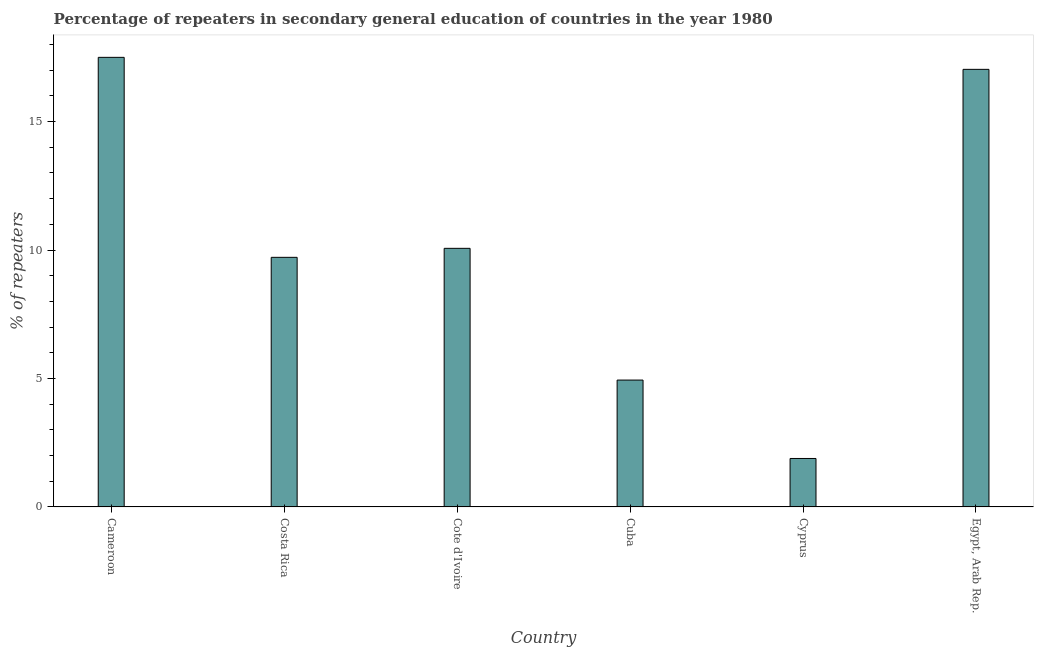Does the graph contain any zero values?
Your response must be concise. No. What is the title of the graph?
Offer a very short reply. Percentage of repeaters in secondary general education of countries in the year 1980. What is the label or title of the X-axis?
Provide a short and direct response. Country. What is the label or title of the Y-axis?
Provide a short and direct response. % of repeaters. What is the percentage of repeaters in Cote d'Ivoire?
Offer a terse response. 10.07. Across all countries, what is the maximum percentage of repeaters?
Provide a short and direct response. 17.5. Across all countries, what is the minimum percentage of repeaters?
Your response must be concise. 1.89. In which country was the percentage of repeaters maximum?
Offer a very short reply. Cameroon. In which country was the percentage of repeaters minimum?
Give a very brief answer. Cyprus. What is the sum of the percentage of repeaters?
Your answer should be compact. 61.13. What is the difference between the percentage of repeaters in Costa Rica and Egypt, Arab Rep.?
Offer a terse response. -7.32. What is the average percentage of repeaters per country?
Provide a short and direct response. 10.19. What is the median percentage of repeaters?
Give a very brief answer. 9.89. What is the ratio of the percentage of repeaters in Costa Rica to that in Cyprus?
Your answer should be very brief. 5.15. Is the percentage of repeaters in Cyprus less than that in Egypt, Arab Rep.?
Keep it short and to the point. Yes. Is the difference between the percentage of repeaters in Cote d'Ivoire and Cuba greater than the difference between any two countries?
Make the answer very short. No. What is the difference between the highest and the second highest percentage of repeaters?
Keep it short and to the point. 0.47. What is the difference between the highest and the lowest percentage of repeaters?
Keep it short and to the point. 15.61. How many bars are there?
Ensure brevity in your answer.  6. What is the difference between two consecutive major ticks on the Y-axis?
Ensure brevity in your answer.  5. Are the values on the major ticks of Y-axis written in scientific E-notation?
Make the answer very short. No. What is the % of repeaters of Cameroon?
Make the answer very short. 17.5. What is the % of repeaters of Costa Rica?
Keep it short and to the point. 9.71. What is the % of repeaters in Cote d'Ivoire?
Your answer should be very brief. 10.07. What is the % of repeaters of Cuba?
Give a very brief answer. 4.94. What is the % of repeaters of Cyprus?
Your response must be concise. 1.89. What is the % of repeaters in Egypt, Arab Rep.?
Offer a terse response. 17.03. What is the difference between the % of repeaters in Cameroon and Costa Rica?
Ensure brevity in your answer.  7.78. What is the difference between the % of repeaters in Cameroon and Cote d'Ivoire?
Provide a short and direct response. 7.43. What is the difference between the % of repeaters in Cameroon and Cuba?
Your answer should be very brief. 12.56. What is the difference between the % of repeaters in Cameroon and Cyprus?
Your response must be concise. 15.61. What is the difference between the % of repeaters in Cameroon and Egypt, Arab Rep.?
Keep it short and to the point. 0.47. What is the difference between the % of repeaters in Costa Rica and Cote d'Ivoire?
Provide a succinct answer. -0.35. What is the difference between the % of repeaters in Costa Rica and Cuba?
Your answer should be compact. 4.78. What is the difference between the % of repeaters in Costa Rica and Cyprus?
Offer a terse response. 7.83. What is the difference between the % of repeaters in Costa Rica and Egypt, Arab Rep.?
Offer a very short reply. -7.32. What is the difference between the % of repeaters in Cote d'Ivoire and Cuba?
Provide a succinct answer. 5.13. What is the difference between the % of repeaters in Cote d'Ivoire and Cyprus?
Offer a very short reply. 8.18. What is the difference between the % of repeaters in Cote d'Ivoire and Egypt, Arab Rep.?
Give a very brief answer. -6.97. What is the difference between the % of repeaters in Cuba and Cyprus?
Your answer should be very brief. 3.05. What is the difference between the % of repeaters in Cuba and Egypt, Arab Rep.?
Make the answer very short. -12.09. What is the difference between the % of repeaters in Cyprus and Egypt, Arab Rep.?
Give a very brief answer. -15.15. What is the ratio of the % of repeaters in Cameroon to that in Costa Rica?
Your answer should be compact. 1.8. What is the ratio of the % of repeaters in Cameroon to that in Cote d'Ivoire?
Give a very brief answer. 1.74. What is the ratio of the % of repeaters in Cameroon to that in Cuba?
Keep it short and to the point. 3.54. What is the ratio of the % of repeaters in Cameroon to that in Cyprus?
Provide a short and direct response. 9.28. What is the ratio of the % of repeaters in Cameroon to that in Egypt, Arab Rep.?
Offer a very short reply. 1.03. What is the ratio of the % of repeaters in Costa Rica to that in Cuba?
Make the answer very short. 1.97. What is the ratio of the % of repeaters in Costa Rica to that in Cyprus?
Keep it short and to the point. 5.15. What is the ratio of the % of repeaters in Costa Rica to that in Egypt, Arab Rep.?
Ensure brevity in your answer.  0.57. What is the ratio of the % of repeaters in Cote d'Ivoire to that in Cuba?
Ensure brevity in your answer.  2.04. What is the ratio of the % of repeaters in Cote d'Ivoire to that in Cyprus?
Your answer should be very brief. 5.34. What is the ratio of the % of repeaters in Cote d'Ivoire to that in Egypt, Arab Rep.?
Keep it short and to the point. 0.59. What is the ratio of the % of repeaters in Cuba to that in Cyprus?
Keep it short and to the point. 2.62. What is the ratio of the % of repeaters in Cuba to that in Egypt, Arab Rep.?
Your answer should be very brief. 0.29. What is the ratio of the % of repeaters in Cyprus to that in Egypt, Arab Rep.?
Give a very brief answer. 0.11. 